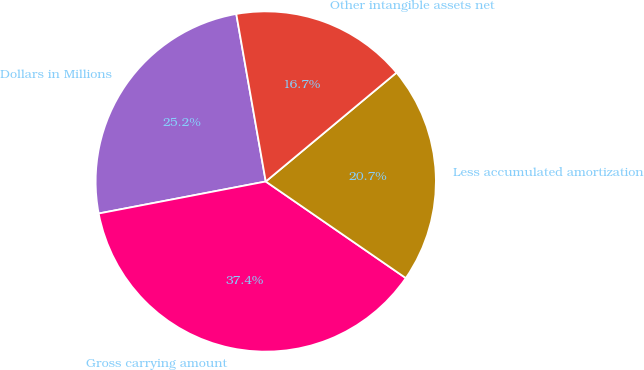<chart> <loc_0><loc_0><loc_500><loc_500><pie_chart><fcel>Dollars in Millions<fcel>Gross carrying amount<fcel>Less accumulated amortization<fcel>Other intangible assets net<nl><fcel>25.24%<fcel>37.38%<fcel>20.66%<fcel>16.72%<nl></chart> 